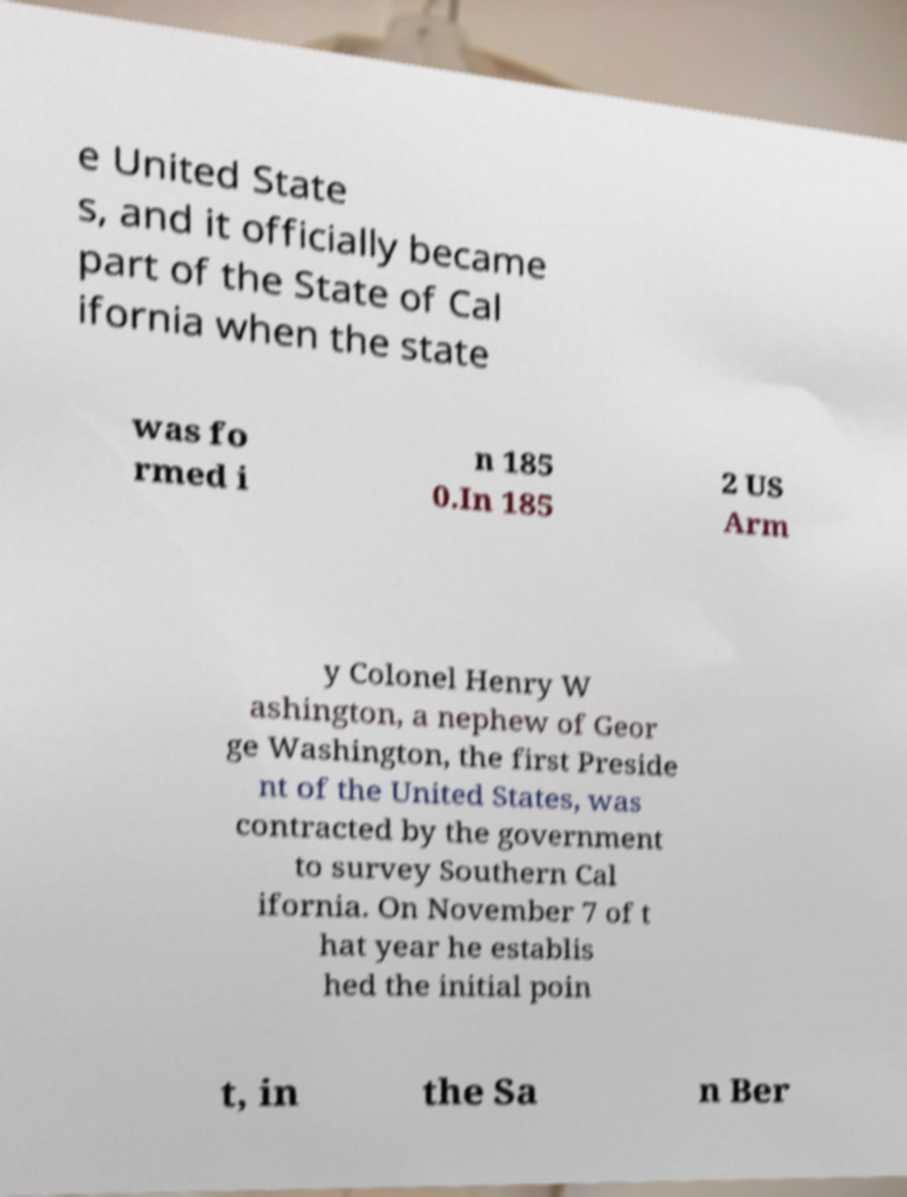Please read and relay the text visible in this image. What does it say? e United State s, and it officially became part of the State of Cal ifornia when the state was fo rmed i n 185 0.In 185 2 US Arm y Colonel Henry W ashington, a nephew of Geor ge Washington, the first Preside nt of the United States, was contracted by the government to survey Southern Cal ifornia. On November 7 of t hat year he establis hed the initial poin t, in the Sa n Ber 